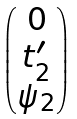Convert formula to latex. <formula><loc_0><loc_0><loc_500><loc_500>\begin{pmatrix} 0 \\ t ^ { \prime } _ { 2 } \\ \psi _ { 2 } \end{pmatrix}</formula> 